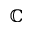<formula> <loc_0><loc_0><loc_500><loc_500>\mathbb { C }</formula> 